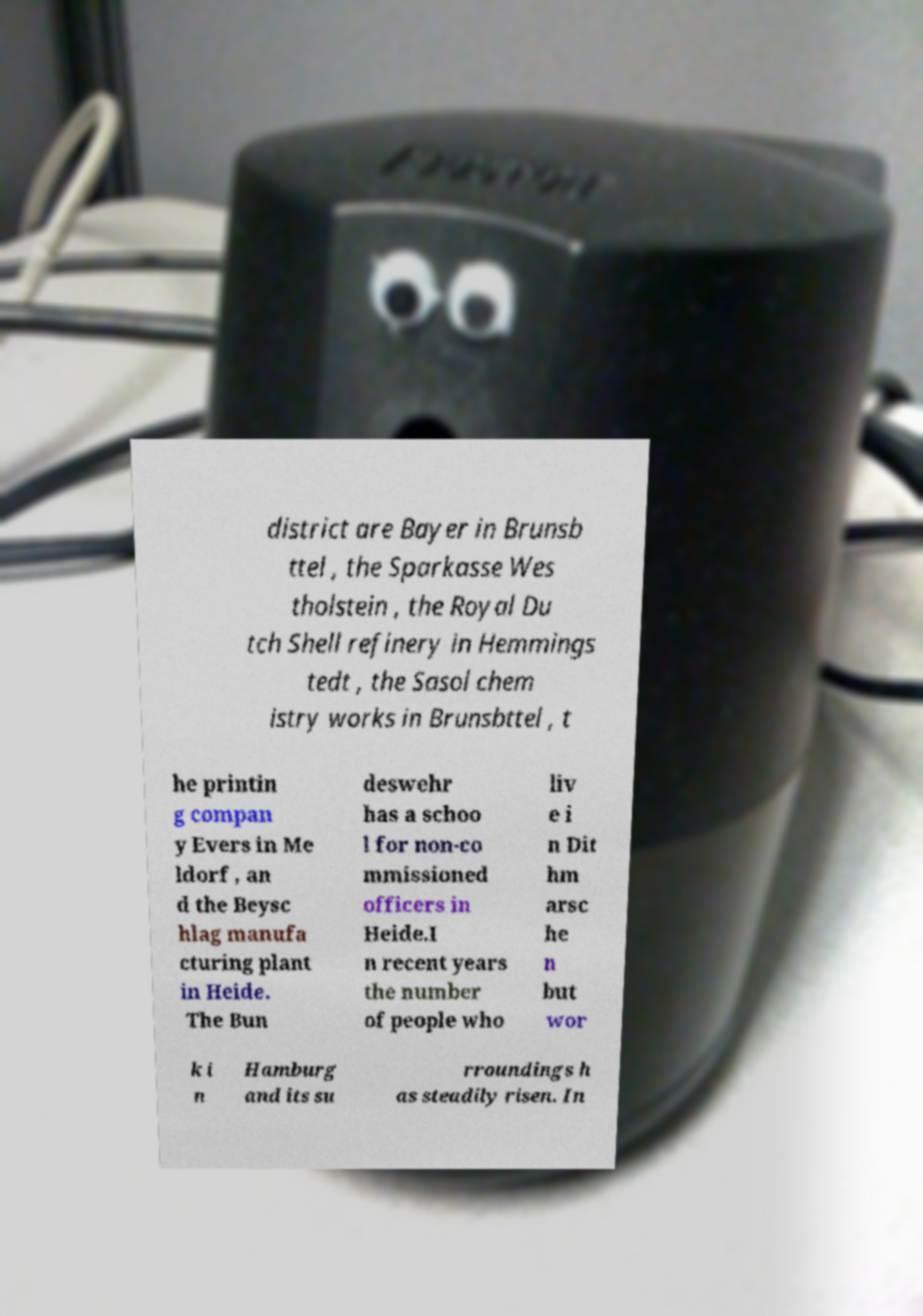Could you assist in decoding the text presented in this image and type it out clearly? district are Bayer in Brunsb ttel , the Sparkasse Wes tholstein , the Royal Du tch Shell refinery in Hemmings tedt , the Sasol chem istry works in Brunsbttel , t he printin g compan y Evers in Me ldorf , an d the Beysc hlag manufa cturing plant in Heide. The Bun deswehr has a schoo l for non-co mmissioned officers in Heide.I n recent years the number of people who liv e i n Dit hm arsc he n but wor k i n Hamburg and its su rroundings h as steadily risen. In 